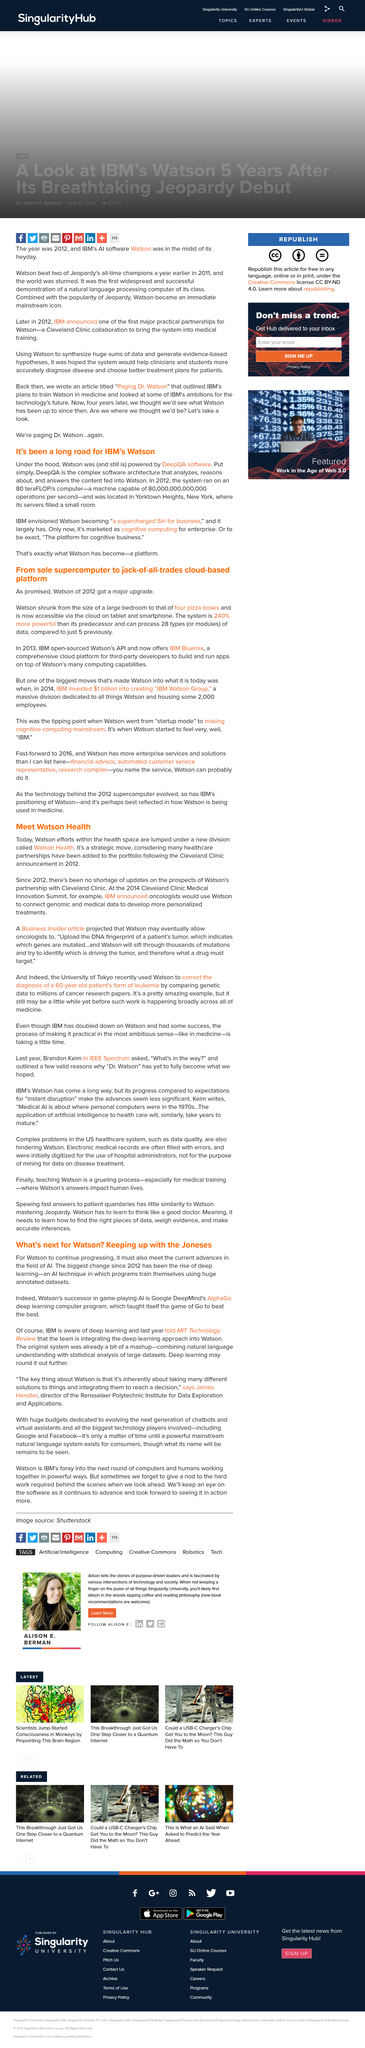Identify some key points in this picture. In 2013, IBM open-sourced Watson's API. There has not been a shortage of updates since 2012. The computer servers were located in Yorktown Heights, New York. Deep learning is a machine learning technique that involves training artificial neural networks on large amounts of labeled data, in order to enable the network to learn and make predictions on new, unseen data. Watson is a cognitive computing platform that is accessible via the cloud on tablet and smartphone. 